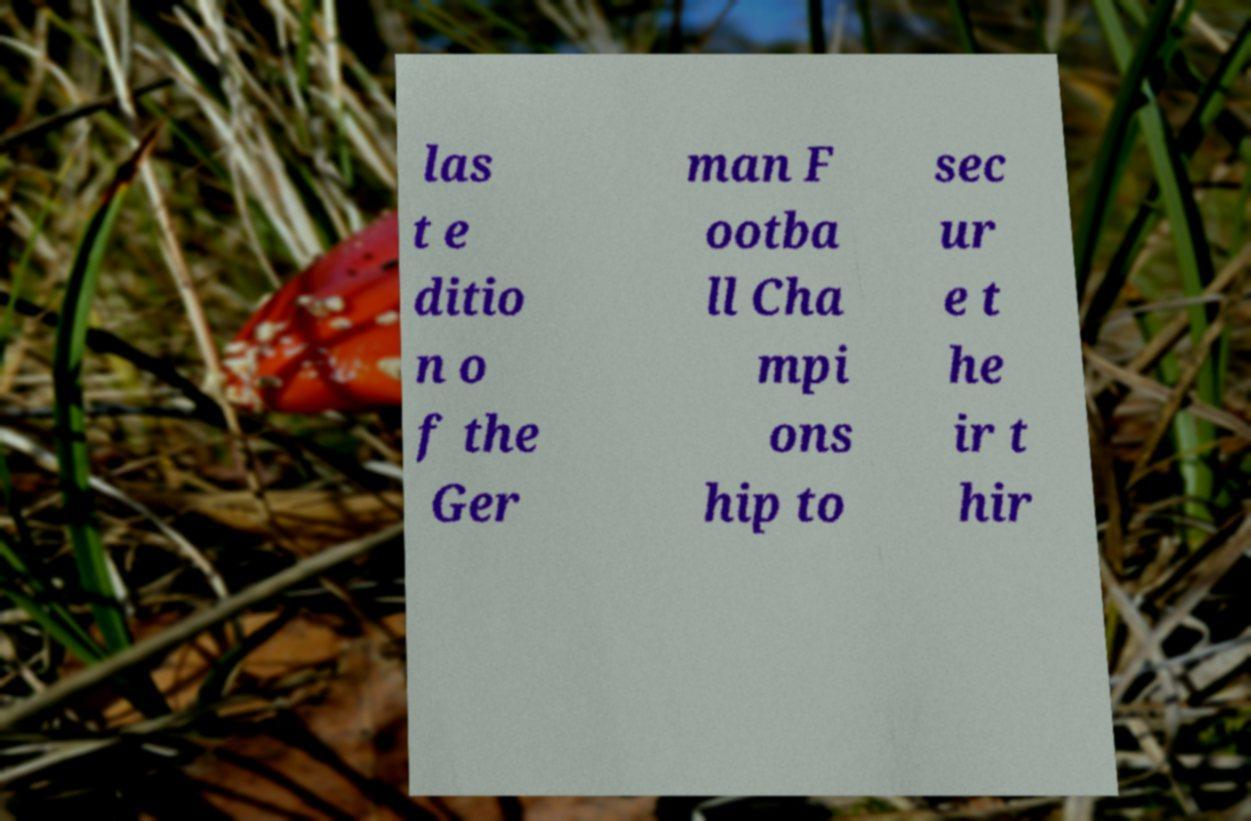Could you extract and type out the text from this image? las t e ditio n o f the Ger man F ootba ll Cha mpi ons hip to sec ur e t he ir t hir 